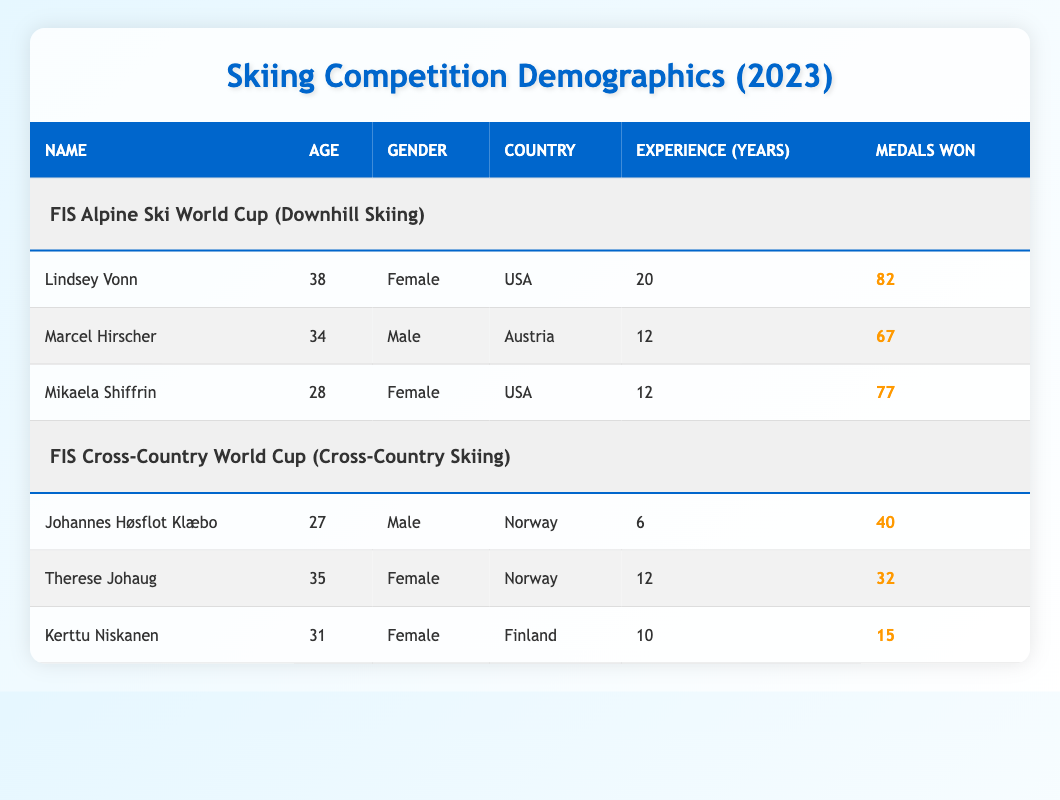What is the age of Lindsey Vonn? Lindsey Vonn's age is listed in the table under the Age column, where it indicates she is 38 years old.
Answer: 38 How many medals has Mikaela Shiffrin won? The table shows that Mikaela Shiffrin has won 77 medals, which can be found in the Medals Won column.
Answer: 77 Is Therese Johaug from Norway? The table indicates that Therese Johaug's country is Norway, confirmed by the value in the Country column for her entry.
Answer: Yes What is the average age of all participants in downhill skiing? The ages of the downhill skiing participants are 38, 34, and 28. Adding these together gives 38 + 34 + 28 = 100. There are 3 participants, so the average age is 100 divided by 3, which is approximately 33.33.
Answer: 33.33 Who has more experience years, Marcel Hirscher or Johannes Høsflot Klæbo? Marcel Hirscher has 12 years of experience while Johannes Høsflot Klæbo has 6 years. Comparing these figures shows that Marcel Hirscher has more experience.
Answer: Marcel Hirscher What is the total number of medals won by the female participants in cross-country skiing? The table shows that Therese Johaug has won 32 medals and Kerttu Niskanen has won 15 medals. Adding these gives 32 + 15 = 47 medals.
Answer: 47 Are there more female participants in downhill skiing than in cross-country skiing? In downhill skiing, there are 2 female participants (Lindsey Vonn and Mikaela Shiffrin), while in cross-country skiing there are also 2 female participants (Therese Johaug and Kerttu Niskanen). Since both numbers are equal, the statement is false.
Answer: No How many more medals has Lindsey Vonn won compared to Kerttu Niskanen? Lindsey Vonn has won 82 medals and Kerttu Niskanen has won 15 medals. The difference is calculated as 82 - 15 = 67 medals.
Answer: 67 Which skiing competition has the participant with the least experience? The table lists the experiences for all participants: Lindsey Vonn (20), Marcel Hirscher (12), Mikaela Shiffrin (12), Johannes Høsflot Klæbo (6), Therese Johaug (12), and Kerttu Niskanen (10). Johannes Høsflot Klæbo has the least experience with 6 years in cross-country skiing.
Answer: FIS Cross-Country World Cup 